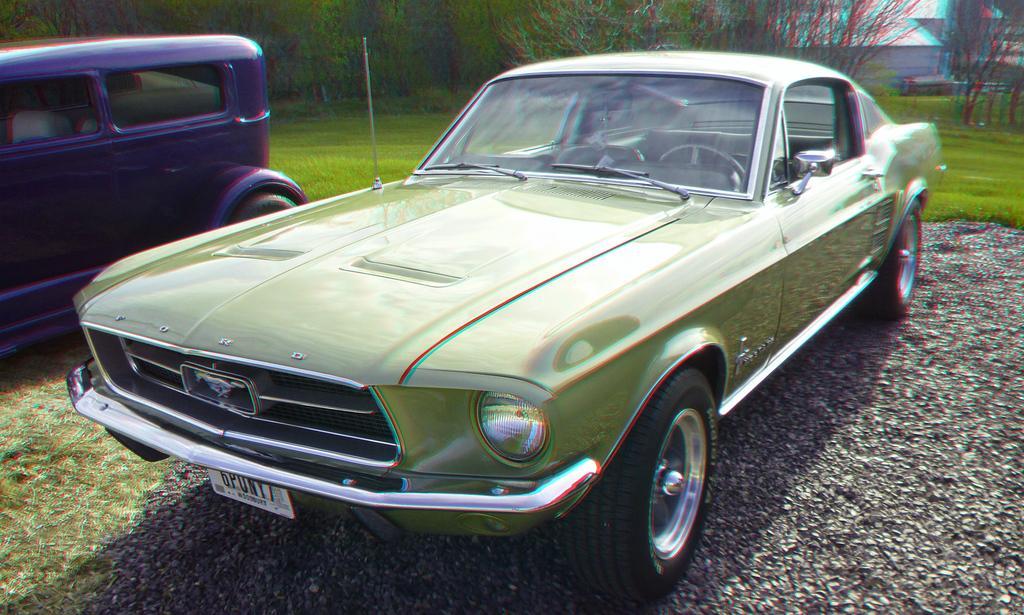In one or two sentences, can you explain what this image depicts? In this image, we can see two cars and there is green grass on the ground, in the background there are some green color trees. 